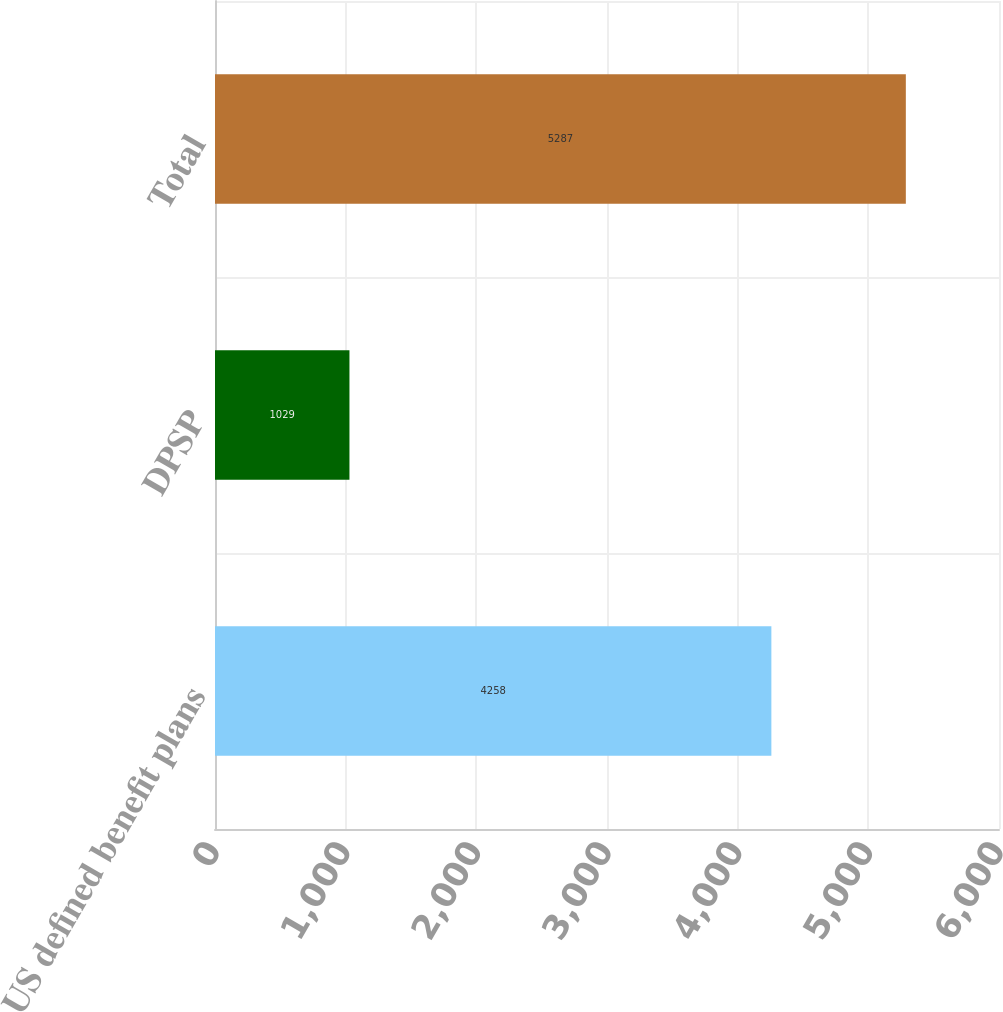<chart> <loc_0><loc_0><loc_500><loc_500><bar_chart><fcel>US defined benefit plans<fcel>DPSP<fcel>Total<nl><fcel>4258<fcel>1029<fcel>5287<nl></chart> 